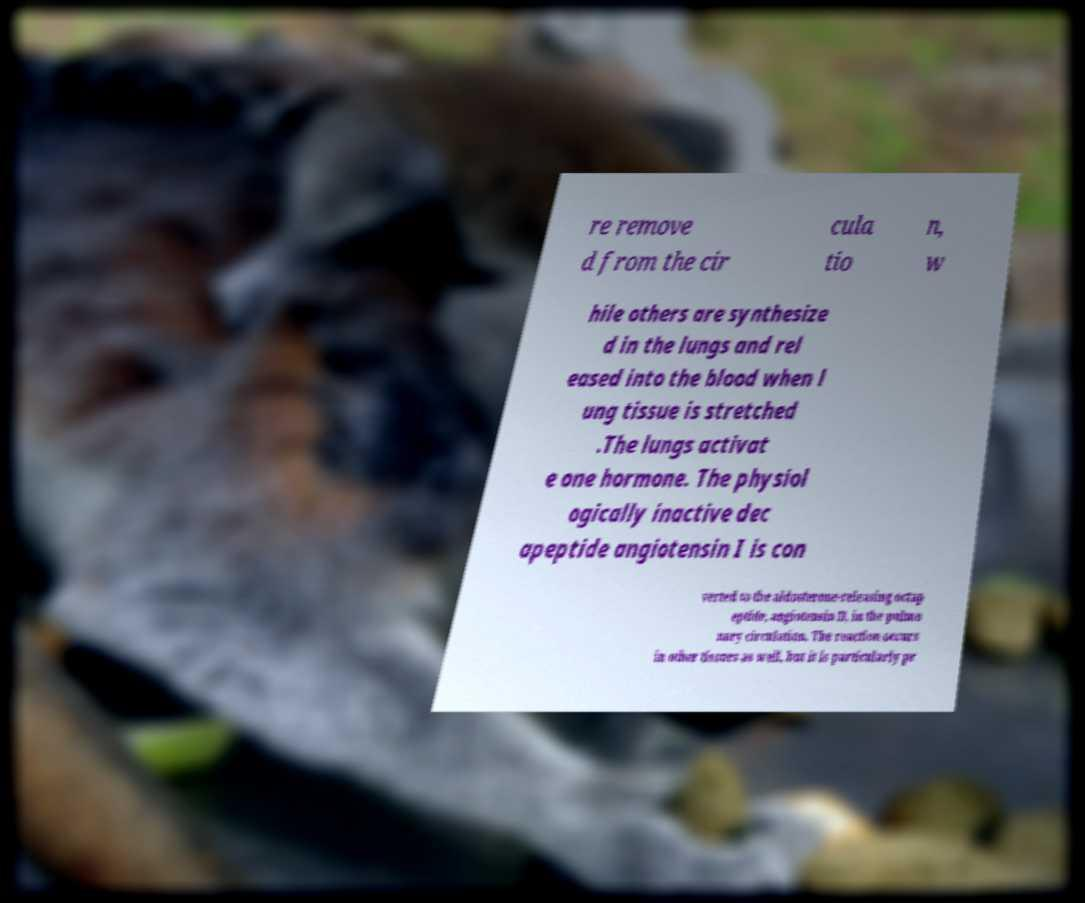Can you accurately transcribe the text from the provided image for me? re remove d from the cir cula tio n, w hile others are synthesize d in the lungs and rel eased into the blood when l ung tissue is stretched .The lungs activat e one hormone. The physiol ogically inactive dec apeptide angiotensin I is con verted to the aldosterone-releasing octap eptide, angiotensin II, in the pulmo nary circulation. The reaction occurs in other tissues as well, but it is particularly pr 